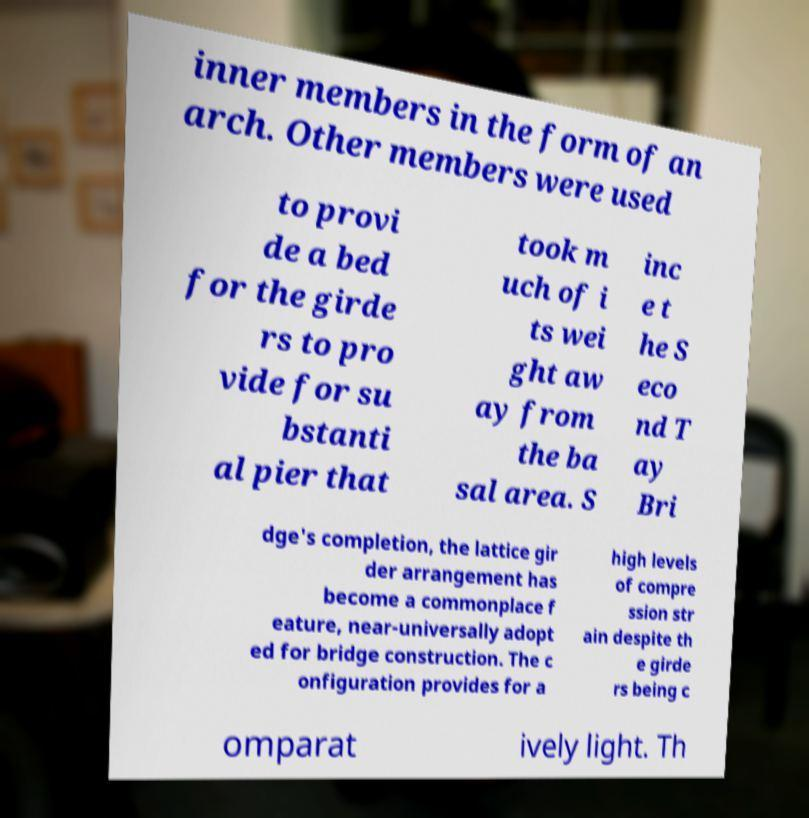Can you read and provide the text displayed in the image?This photo seems to have some interesting text. Can you extract and type it out for me? inner members in the form of an arch. Other members were used to provi de a bed for the girde rs to pro vide for su bstanti al pier that took m uch of i ts wei ght aw ay from the ba sal area. S inc e t he S eco nd T ay Bri dge's completion, the lattice gir der arrangement has become a commonplace f eature, near-universally adopt ed for bridge construction. The c onfiguration provides for a high levels of compre ssion str ain despite th e girde rs being c omparat ively light. Th 